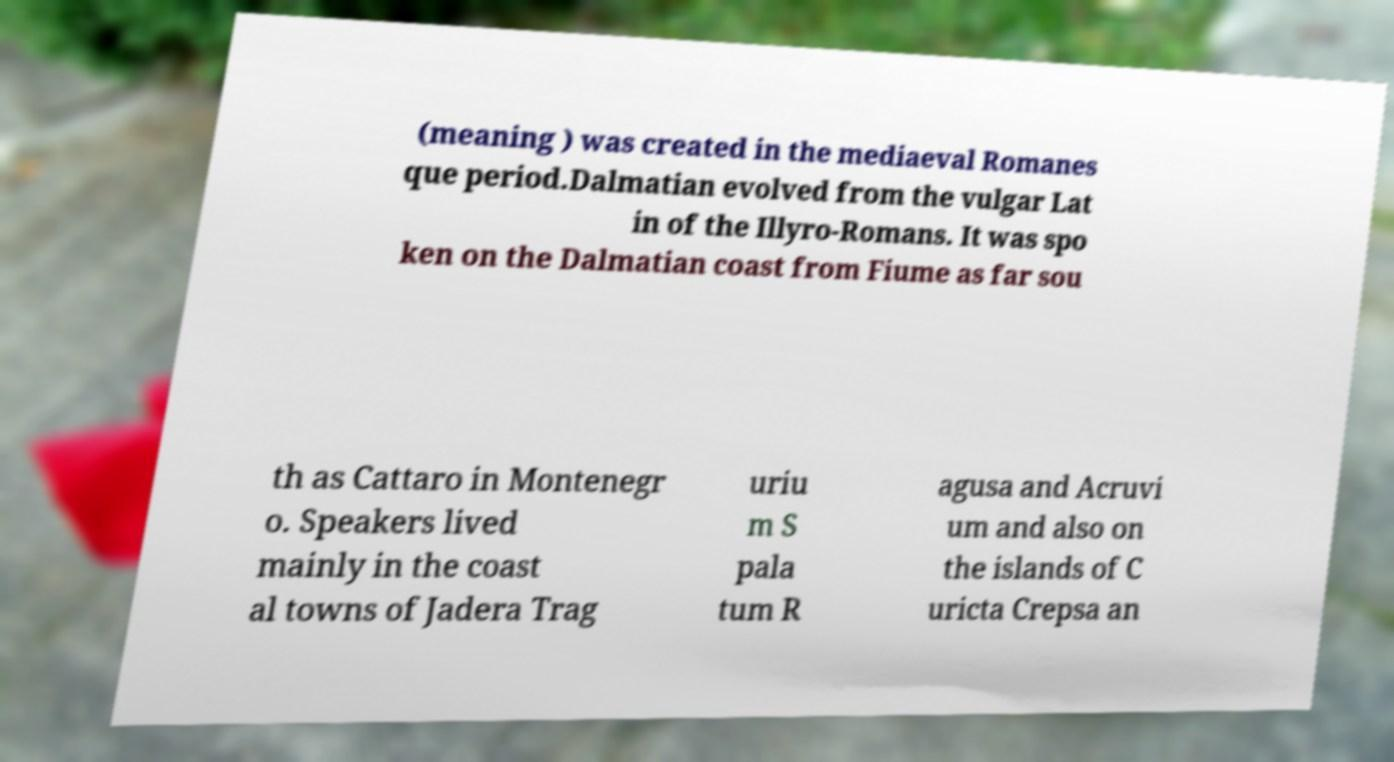Could you assist in decoding the text presented in this image and type it out clearly? (meaning ) was created in the mediaeval Romanes que period.Dalmatian evolved from the vulgar Lat in of the Illyro-Romans. It was spo ken on the Dalmatian coast from Fiume as far sou th as Cattaro in Montenegr o. Speakers lived mainly in the coast al towns of Jadera Trag uriu m S pala tum R agusa and Acruvi um and also on the islands of C uricta Crepsa an 